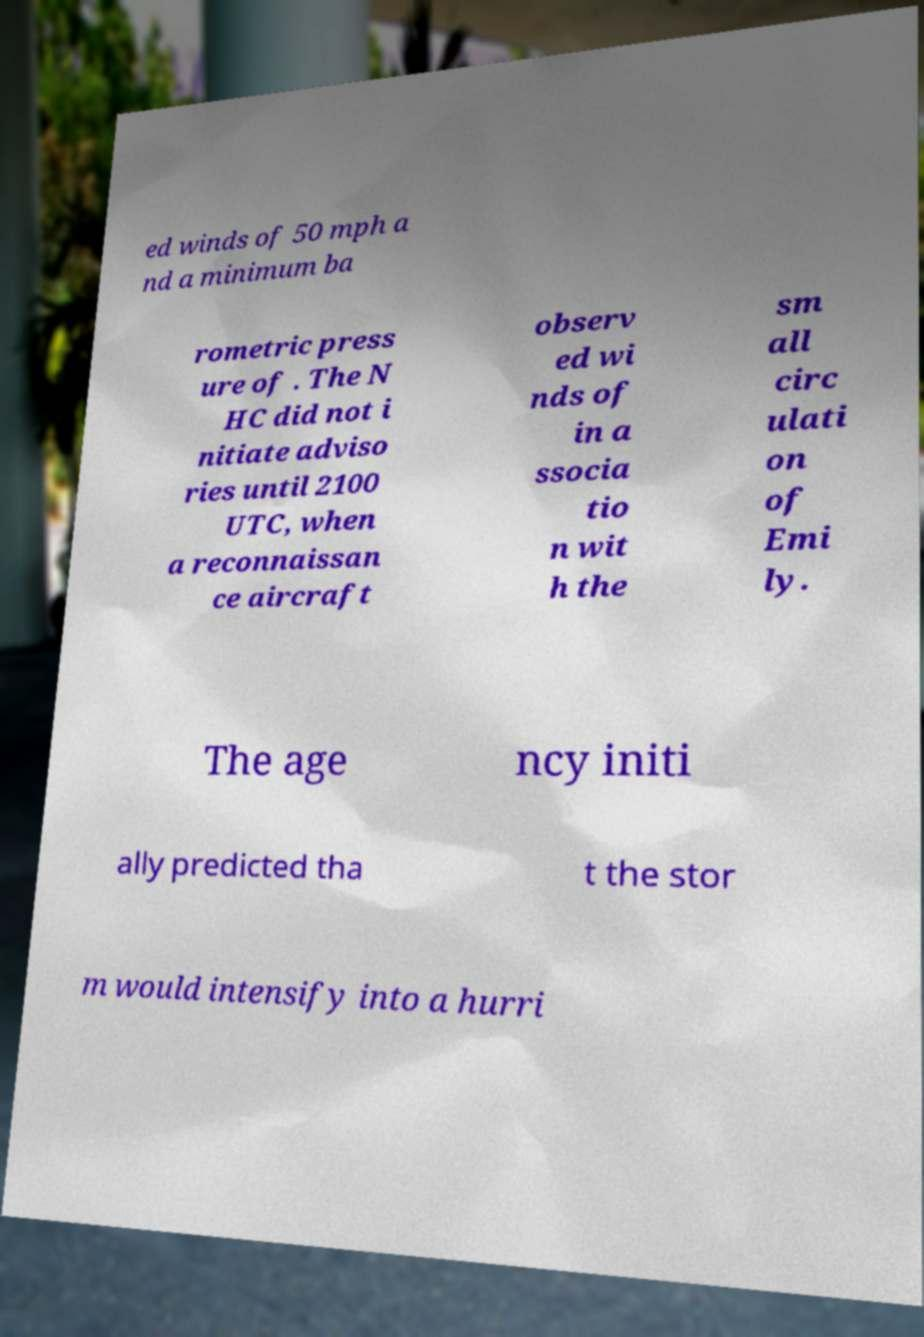Can you accurately transcribe the text from the provided image for me? ed winds of 50 mph a nd a minimum ba rometric press ure of . The N HC did not i nitiate adviso ries until 2100 UTC, when a reconnaissan ce aircraft observ ed wi nds of in a ssocia tio n wit h the sm all circ ulati on of Emi ly. The age ncy initi ally predicted tha t the stor m would intensify into a hurri 